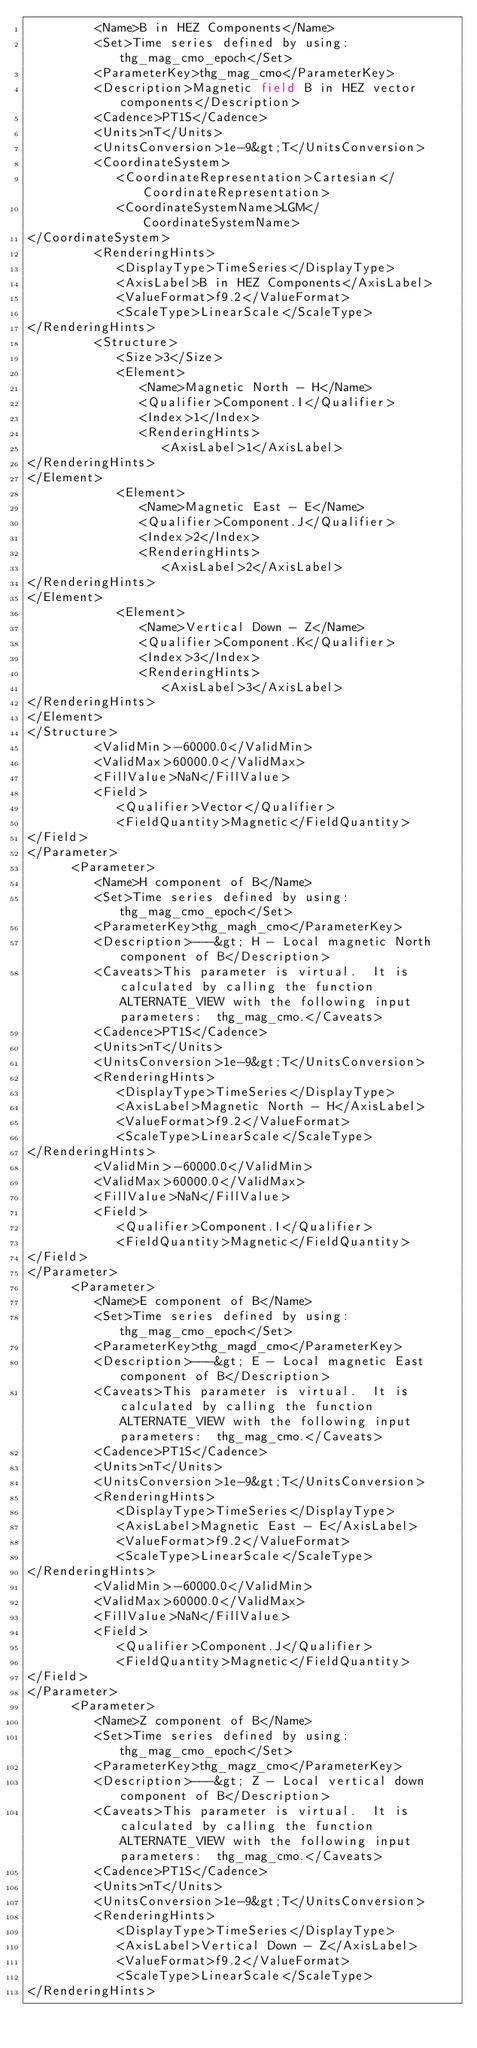Convert code to text. <code><loc_0><loc_0><loc_500><loc_500><_XML_>         <Name>B in HEZ Components</Name>
         <Set>Time series defined by using: thg_mag_cmo_epoch</Set>
         <ParameterKey>thg_mag_cmo</ParameterKey>
         <Description>Magnetic field B in HEZ vector components</Description>
         <Cadence>PT1S</Cadence>
         <Units>nT</Units>
         <UnitsConversion>1e-9&gt;T</UnitsConversion>
         <CoordinateSystem>
            <CoordinateRepresentation>Cartesian</CoordinateRepresentation>
            <CoordinateSystemName>LGM</CoordinateSystemName>
</CoordinateSystem>
         <RenderingHints>
            <DisplayType>TimeSeries</DisplayType>
            <AxisLabel>B in HEZ Components</AxisLabel>
            <ValueFormat>f9.2</ValueFormat>
            <ScaleType>LinearScale</ScaleType>
</RenderingHints>
         <Structure>
            <Size>3</Size>
            <Element>
               <Name>Magnetic North - H</Name>
               <Qualifier>Component.I</Qualifier>
               <Index>1</Index>
               <RenderingHints>
                  <AxisLabel>1</AxisLabel>
</RenderingHints>
</Element>
            <Element>
               <Name>Magnetic East - E</Name>
               <Qualifier>Component.J</Qualifier>
               <Index>2</Index>
               <RenderingHints>
                  <AxisLabel>2</AxisLabel>
</RenderingHints>
</Element>
            <Element>
               <Name>Vertical Down - Z</Name>
               <Qualifier>Component.K</Qualifier>
               <Index>3</Index>
               <RenderingHints>
                  <AxisLabel>3</AxisLabel>
</RenderingHints>
</Element>
</Structure>
         <ValidMin>-60000.0</ValidMin>
         <ValidMax>60000.0</ValidMax>
         <FillValue>NaN</FillValue>
         <Field>
            <Qualifier>Vector</Qualifier>
            <FieldQuantity>Magnetic</FieldQuantity>
</Field>
</Parameter>
      <Parameter>
         <Name>H component of B</Name>
         <Set>Time series defined by using: thg_mag_cmo_epoch</Set>
         <ParameterKey>thg_magh_cmo</ParameterKey>
         <Description>---&gt; H - Local magnetic North component of B</Description>
         <Caveats>This parameter is virtual.  It is calculated by calling the function ALTERNATE_VIEW with the following input parameters:  thg_mag_cmo.</Caveats>
         <Cadence>PT1S</Cadence>
         <Units>nT</Units>
         <UnitsConversion>1e-9&gt;T</UnitsConversion>
         <RenderingHints>
            <DisplayType>TimeSeries</DisplayType>
            <AxisLabel>Magnetic North - H</AxisLabel>
            <ValueFormat>f9.2</ValueFormat>
            <ScaleType>LinearScale</ScaleType>
</RenderingHints>
         <ValidMin>-60000.0</ValidMin>
         <ValidMax>60000.0</ValidMax>
         <FillValue>NaN</FillValue>
         <Field>
            <Qualifier>Component.I</Qualifier>
            <FieldQuantity>Magnetic</FieldQuantity>
</Field>
</Parameter>
      <Parameter>
         <Name>E component of B</Name>
         <Set>Time series defined by using: thg_mag_cmo_epoch</Set>
         <ParameterKey>thg_magd_cmo</ParameterKey>
         <Description>---&gt; E - Local magnetic East component of B</Description>
         <Caveats>This parameter is virtual.  It is calculated by calling the function ALTERNATE_VIEW with the following input parameters:  thg_mag_cmo.</Caveats>
         <Cadence>PT1S</Cadence>
         <Units>nT</Units>
         <UnitsConversion>1e-9&gt;T</UnitsConversion>
         <RenderingHints>
            <DisplayType>TimeSeries</DisplayType>
            <AxisLabel>Magnetic East - E</AxisLabel>
            <ValueFormat>f9.2</ValueFormat>
            <ScaleType>LinearScale</ScaleType>
</RenderingHints>
         <ValidMin>-60000.0</ValidMin>
         <ValidMax>60000.0</ValidMax>
         <FillValue>NaN</FillValue>
         <Field>
            <Qualifier>Component.J</Qualifier>
            <FieldQuantity>Magnetic</FieldQuantity>
</Field>
</Parameter>
      <Parameter>
         <Name>Z component of B</Name>
         <Set>Time series defined by using: thg_mag_cmo_epoch</Set>
         <ParameterKey>thg_magz_cmo</ParameterKey>
         <Description>---&gt; Z - Local vertical down component of B</Description>
         <Caveats>This parameter is virtual.  It is calculated by calling the function ALTERNATE_VIEW with the following input parameters:  thg_mag_cmo.</Caveats>
         <Cadence>PT1S</Cadence>
         <Units>nT</Units>
         <UnitsConversion>1e-9&gt;T</UnitsConversion>
         <RenderingHints>
            <DisplayType>TimeSeries</DisplayType>
            <AxisLabel>Vertical Down - Z</AxisLabel>
            <ValueFormat>f9.2</ValueFormat>
            <ScaleType>LinearScale</ScaleType>
</RenderingHints></code> 